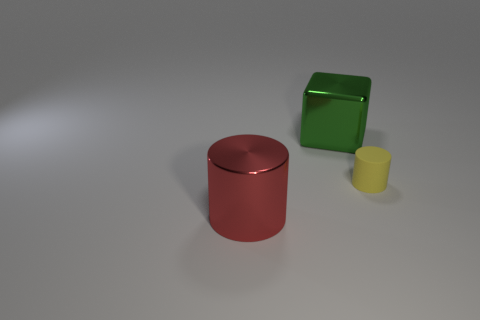What number of metal objects are either large green blocks or red things?
Give a very brief answer. 2. Is there a metallic thing that is in front of the large shiny thing that is right of the cylinder on the left side of the green block?
Offer a very short reply. Yes. The small rubber thing has what color?
Offer a very short reply. Yellow. There is a big metal thing that is in front of the tiny cylinder; is it the same shape as the small yellow thing?
Ensure brevity in your answer.  Yes. What number of things are either cubes or big metallic objects that are behind the shiny cylinder?
Provide a short and direct response. 1. Is the large object that is behind the yellow cylinder made of the same material as the large red cylinder?
Your response must be concise. Yes. Is there any other thing that is the same size as the yellow rubber object?
Provide a succinct answer. No. There is a big red thing left of the large metallic object behind the yellow thing; what is it made of?
Provide a succinct answer. Metal. Are there more large objects to the left of the big green object than big cubes on the left side of the large shiny cylinder?
Give a very brief answer. Yes. How big is the shiny cylinder?
Provide a succinct answer. Large. 